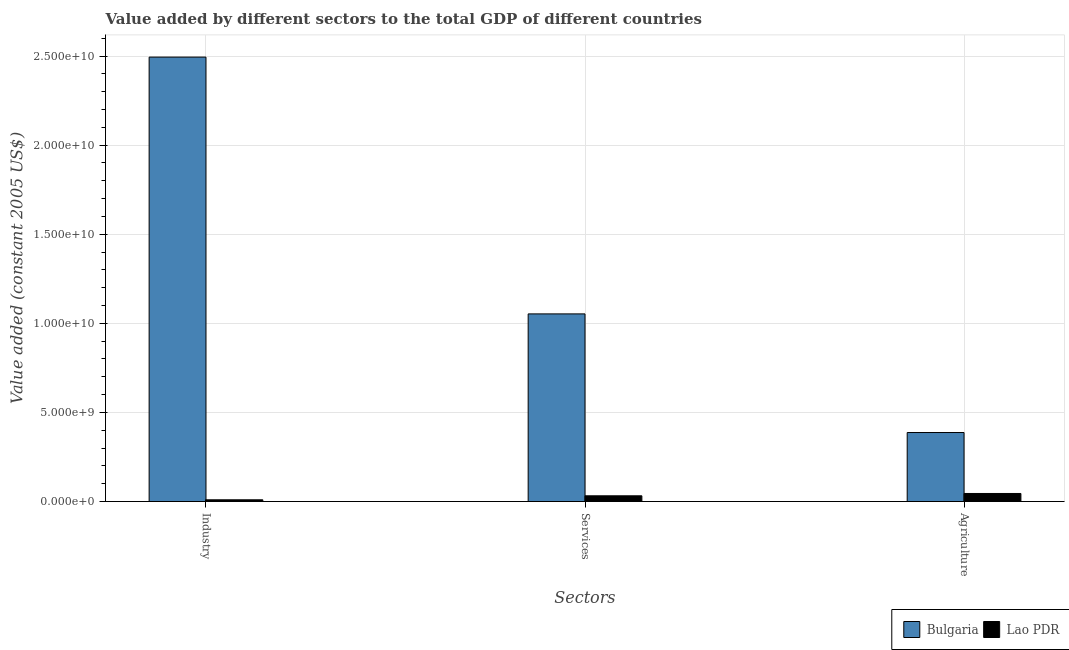How many groups of bars are there?
Offer a terse response. 3. Are the number of bars on each tick of the X-axis equal?
Provide a succinct answer. Yes. How many bars are there on the 2nd tick from the left?
Provide a succinct answer. 2. How many bars are there on the 1st tick from the right?
Provide a short and direct response. 2. What is the label of the 3rd group of bars from the left?
Provide a short and direct response. Agriculture. What is the value added by industrial sector in Lao PDR?
Your answer should be compact. 9.84e+07. Across all countries, what is the maximum value added by industrial sector?
Your answer should be compact. 2.49e+1. Across all countries, what is the minimum value added by services?
Your response must be concise. 3.23e+08. In which country was the value added by services maximum?
Your response must be concise. Bulgaria. In which country was the value added by services minimum?
Your answer should be compact. Lao PDR. What is the total value added by agricultural sector in the graph?
Your answer should be compact. 4.33e+09. What is the difference between the value added by services in Lao PDR and that in Bulgaria?
Make the answer very short. -1.02e+1. What is the difference between the value added by services in Lao PDR and the value added by industrial sector in Bulgaria?
Offer a terse response. -2.46e+1. What is the average value added by agricultural sector per country?
Keep it short and to the point. 2.16e+09. What is the difference between the value added by industrial sector and value added by services in Bulgaria?
Ensure brevity in your answer.  1.44e+1. What is the ratio of the value added by industrial sector in Bulgaria to that in Lao PDR?
Offer a very short reply. 253.43. What is the difference between the highest and the second highest value added by services?
Your answer should be compact. 1.02e+1. What is the difference between the highest and the lowest value added by services?
Offer a terse response. 1.02e+1. What does the 1st bar from the left in Agriculture represents?
Your answer should be compact. Bulgaria. What does the 1st bar from the right in Agriculture represents?
Keep it short and to the point. Lao PDR. Is it the case that in every country, the sum of the value added by industrial sector and value added by services is greater than the value added by agricultural sector?
Your answer should be very brief. No. How many bars are there?
Your response must be concise. 6. Are all the bars in the graph horizontal?
Make the answer very short. No. Are the values on the major ticks of Y-axis written in scientific E-notation?
Ensure brevity in your answer.  Yes. Does the graph contain any zero values?
Give a very brief answer. No. What is the title of the graph?
Offer a very short reply. Value added by different sectors to the total GDP of different countries. What is the label or title of the X-axis?
Offer a terse response. Sectors. What is the label or title of the Y-axis?
Give a very brief answer. Value added (constant 2005 US$). What is the Value added (constant 2005 US$) of Bulgaria in Industry?
Make the answer very short. 2.49e+1. What is the Value added (constant 2005 US$) in Lao PDR in Industry?
Your response must be concise. 9.84e+07. What is the Value added (constant 2005 US$) of Bulgaria in Services?
Ensure brevity in your answer.  1.05e+1. What is the Value added (constant 2005 US$) in Lao PDR in Services?
Your answer should be compact. 3.23e+08. What is the Value added (constant 2005 US$) of Bulgaria in Agriculture?
Provide a succinct answer. 3.87e+09. What is the Value added (constant 2005 US$) in Lao PDR in Agriculture?
Provide a short and direct response. 4.53e+08. Across all Sectors, what is the maximum Value added (constant 2005 US$) in Bulgaria?
Make the answer very short. 2.49e+1. Across all Sectors, what is the maximum Value added (constant 2005 US$) in Lao PDR?
Provide a short and direct response. 4.53e+08. Across all Sectors, what is the minimum Value added (constant 2005 US$) of Bulgaria?
Make the answer very short. 3.87e+09. Across all Sectors, what is the minimum Value added (constant 2005 US$) in Lao PDR?
Ensure brevity in your answer.  9.84e+07. What is the total Value added (constant 2005 US$) of Bulgaria in the graph?
Your answer should be very brief. 3.93e+1. What is the total Value added (constant 2005 US$) in Lao PDR in the graph?
Provide a short and direct response. 8.75e+08. What is the difference between the Value added (constant 2005 US$) of Bulgaria in Industry and that in Services?
Your answer should be compact. 1.44e+1. What is the difference between the Value added (constant 2005 US$) in Lao PDR in Industry and that in Services?
Your answer should be very brief. -2.25e+08. What is the difference between the Value added (constant 2005 US$) in Bulgaria in Industry and that in Agriculture?
Keep it short and to the point. 2.11e+1. What is the difference between the Value added (constant 2005 US$) of Lao PDR in Industry and that in Agriculture?
Your answer should be very brief. -3.55e+08. What is the difference between the Value added (constant 2005 US$) in Bulgaria in Services and that in Agriculture?
Provide a short and direct response. 6.66e+09. What is the difference between the Value added (constant 2005 US$) in Lao PDR in Services and that in Agriculture?
Give a very brief answer. -1.30e+08. What is the difference between the Value added (constant 2005 US$) in Bulgaria in Industry and the Value added (constant 2005 US$) in Lao PDR in Services?
Offer a very short reply. 2.46e+1. What is the difference between the Value added (constant 2005 US$) of Bulgaria in Industry and the Value added (constant 2005 US$) of Lao PDR in Agriculture?
Your answer should be very brief. 2.45e+1. What is the difference between the Value added (constant 2005 US$) in Bulgaria in Services and the Value added (constant 2005 US$) in Lao PDR in Agriculture?
Provide a succinct answer. 1.01e+1. What is the average Value added (constant 2005 US$) of Bulgaria per Sectors?
Make the answer very short. 1.31e+1. What is the average Value added (constant 2005 US$) of Lao PDR per Sectors?
Make the answer very short. 2.92e+08. What is the difference between the Value added (constant 2005 US$) in Bulgaria and Value added (constant 2005 US$) in Lao PDR in Industry?
Your answer should be compact. 2.48e+1. What is the difference between the Value added (constant 2005 US$) in Bulgaria and Value added (constant 2005 US$) in Lao PDR in Services?
Make the answer very short. 1.02e+1. What is the difference between the Value added (constant 2005 US$) in Bulgaria and Value added (constant 2005 US$) in Lao PDR in Agriculture?
Offer a terse response. 3.42e+09. What is the ratio of the Value added (constant 2005 US$) of Bulgaria in Industry to that in Services?
Your answer should be very brief. 2.37. What is the ratio of the Value added (constant 2005 US$) of Lao PDR in Industry to that in Services?
Your answer should be compact. 0.3. What is the ratio of the Value added (constant 2005 US$) in Bulgaria in Industry to that in Agriculture?
Offer a very short reply. 6.44. What is the ratio of the Value added (constant 2005 US$) in Lao PDR in Industry to that in Agriculture?
Ensure brevity in your answer.  0.22. What is the ratio of the Value added (constant 2005 US$) in Bulgaria in Services to that in Agriculture?
Give a very brief answer. 2.72. What is the ratio of the Value added (constant 2005 US$) in Lao PDR in Services to that in Agriculture?
Keep it short and to the point. 0.71. What is the difference between the highest and the second highest Value added (constant 2005 US$) of Bulgaria?
Your answer should be very brief. 1.44e+1. What is the difference between the highest and the second highest Value added (constant 2005 US$) in Lao PDR?
Your answer should be compact. 1.30e+08. What is the difference between the highest and the lowest Value added (constant 2005 US$) in Bulgaria?
Offer a very short reply. 2.11e+1. What is the difference between the highest and the lowest Value added (constant 2005 US$) in Lao PDR?
Offer a terse response. 3.55e+08. 